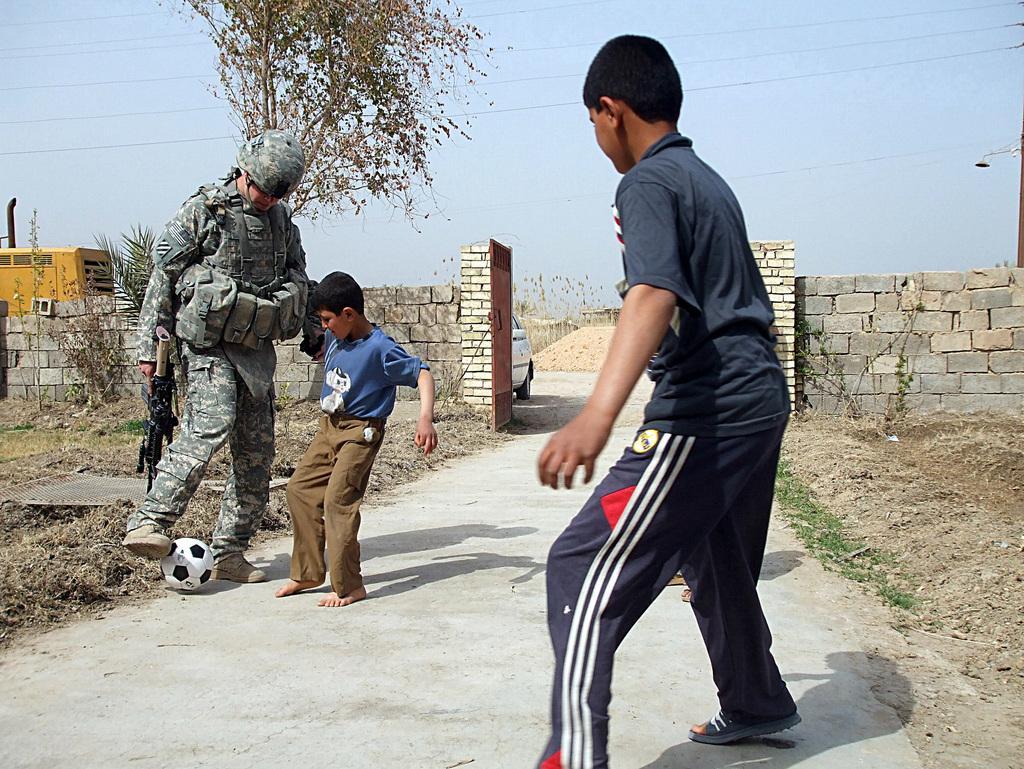Please provide a concise description of this image. On the left side, there is a person in uniform, holding a gun with a hand and playing with a ball on a road. In front of him, there is a child. On the right side, there are two persons. In the background, there is a brick wall, vehicles on the road, there are trees, plants, cables and there are clouds in the sky. 